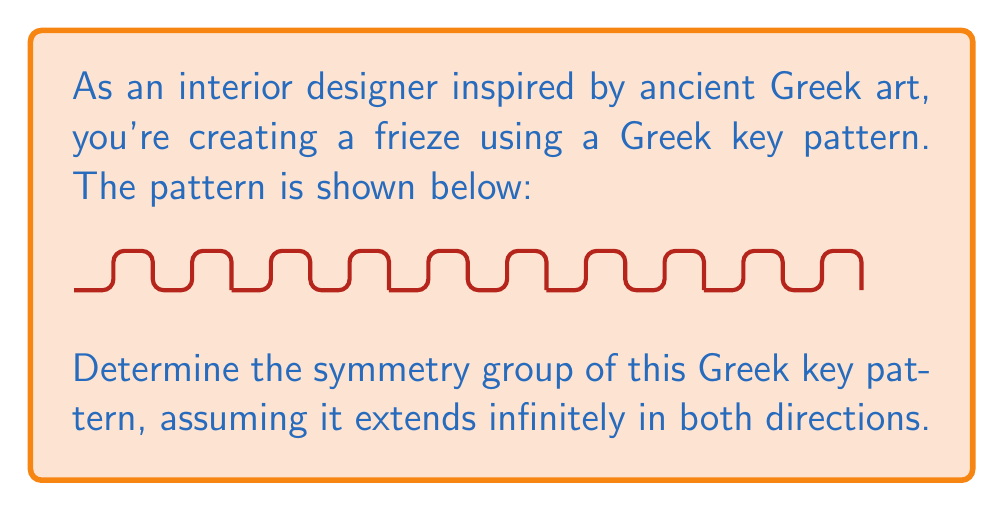Give your solution to this math problem. To determine the symmetry group of this Greek key pattern, we need to identify all the symmetry operations that leave the pattern unchanged. Let's analyze step-by-step:

1. Translations:
   The pattern repeats every 4 units horizontally. Thus, we have translational symmetry $T_4$, where $T_4$ represents a translation by 4 units.

2. Rotations:
   There are no rotational symmetries in this pattern, as rotating by any angle doesn't preserve the pattern.

3. Reflections:
   - Vertical reflections: There are vertical reflection lines at every 2 units (middle of each key and between keys).
   - Horizontal reflections: There are no horizontal reflection lines.

4. Glide reflections:
   There is a glide reflection with a horizontal glide of 2 units followed by a vertical reflection.

The symmetry group of this pattern is known as the frieze group $p m g$, where:
- $p$ indicates a primitive cell (no centering)
- $m$ indicates the presence of mirror reflection perpendicular to the frieze direction
- $g$ indicates the presence of glide reflection

This group is generated by:
- Translation $T_4$
- Vertical reflection $m$
- Glide reflection $g$

The full set of symmetries in this group can be described as:
$$ \{e, T_4, T_8, ..., m, mT_4, mT_8, ..., g, gT_4, gT_8, ...\} $$

where $e$ is the identity operation.
Answer: Frieze group $pmg$ 